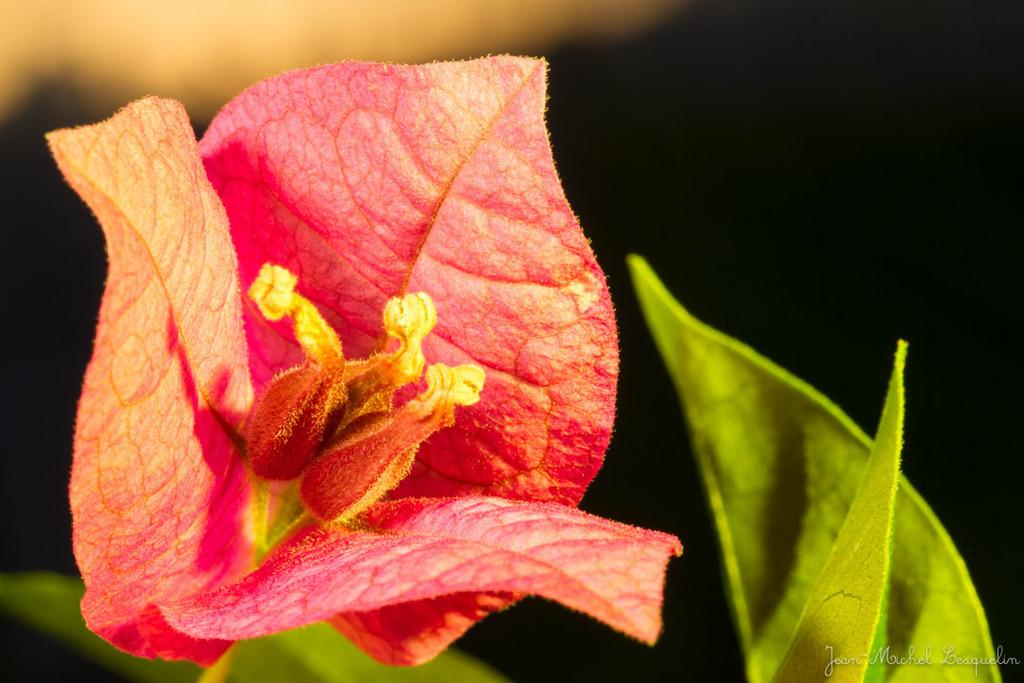What type of plant can be seen in the image? The image contains a flower. What color is the flower? The flower is red in color. Are there any additional parts of the plant visible in the image? Yes, there are leaves associated with the flower. What can be found in the bottom right corner of the image? There is text in the bottom right corner of the image. What is the queen arguing about with the flower in the image? There is no queen or argument present in the image; it features a red flower with leaves and text in the bottom right corner. 